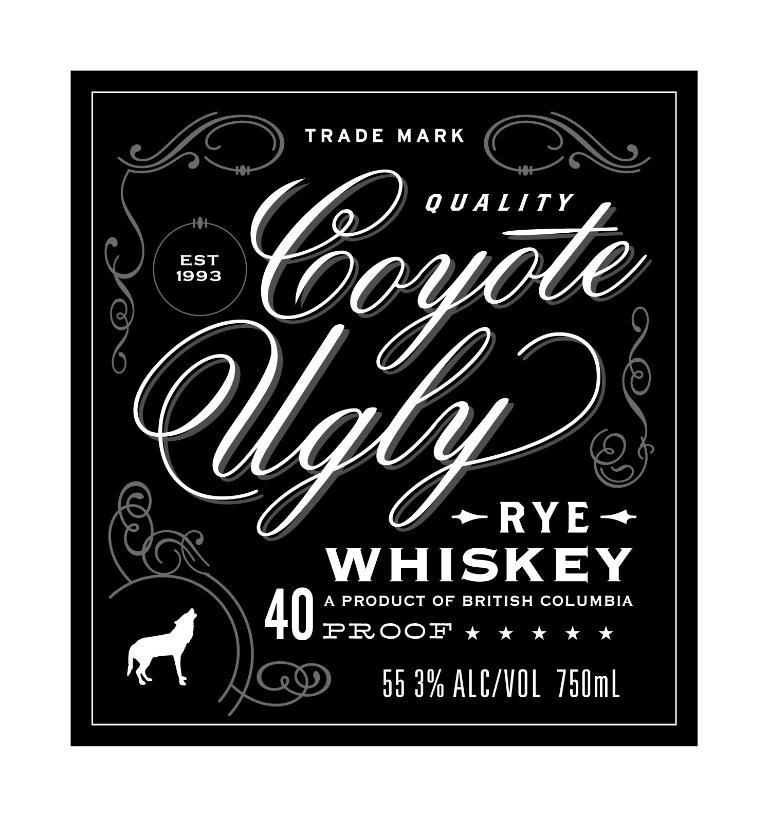<image>
Present a compact description of the photo's key features. A black label with the words Coyote Ugly on it. 